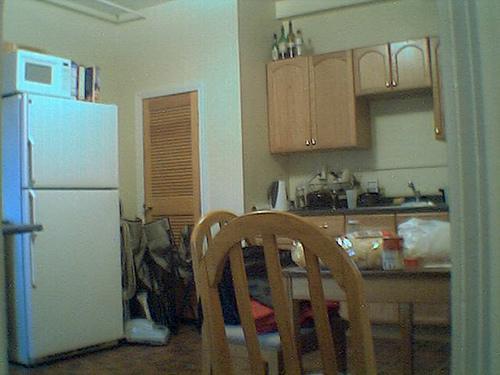How many doors does the fridge have?
Give a very brief answer. 2. How many doorways are visible?
Give a very brief answer. 1. How many chairs are here?
Give a very brief answer. 2. How many red chairs are there?
Give a very brief answer. 0. How many chairs are there?
Give a very brief answer. 2. How many people are shown?
Give a very brief answer. 0. 